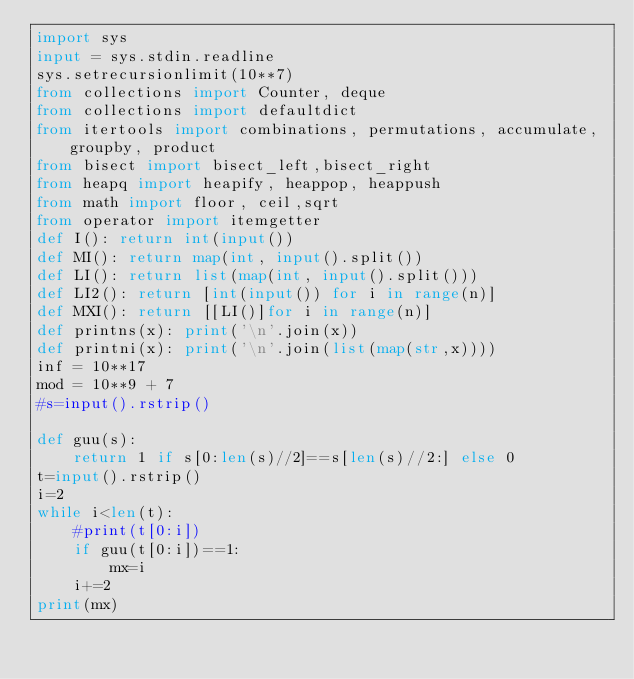Convert code to text. <code><loc_0><loc_0><loc_500><loc_500><_Python_>import sys
input = sys.stdin.readline
sys.setrecursionlimit(10**7)
from collections import Counter, deque
from collections import defaultdict
from itertools import combinations, permutations, accumulate, groupby, product
from bisect import bisect_left,bisect_right
from heapq import heapify, heappop, heappush
from math import floor, ceil,sqrt
from operator import itemgetter
def I(): return int(input())
def MI(): return map(int, input().split())
def LI(): return list(map(int, input().split()))
def LI2(): return [int(input()) for i in range(n)]
def MXI(): return [[LI()]for i in range(n)]
def printns(x): print('\n'.join(x))
def printni(x): print('\n'.join(list(map(str,x))))
inf = 10**17
mod = 10**9 + 7
#s=input().rstrip()

def guu(s):
    return 1 if s[0:len(s)//2]==s[len(s)//2:] else 0
t=input().rstrip()
i=2
while i<len(t):
    #print(t[0:i])
    if guu(t[0:i])==1:
        mx=i
    i+=2
print(mx)
        </code> 